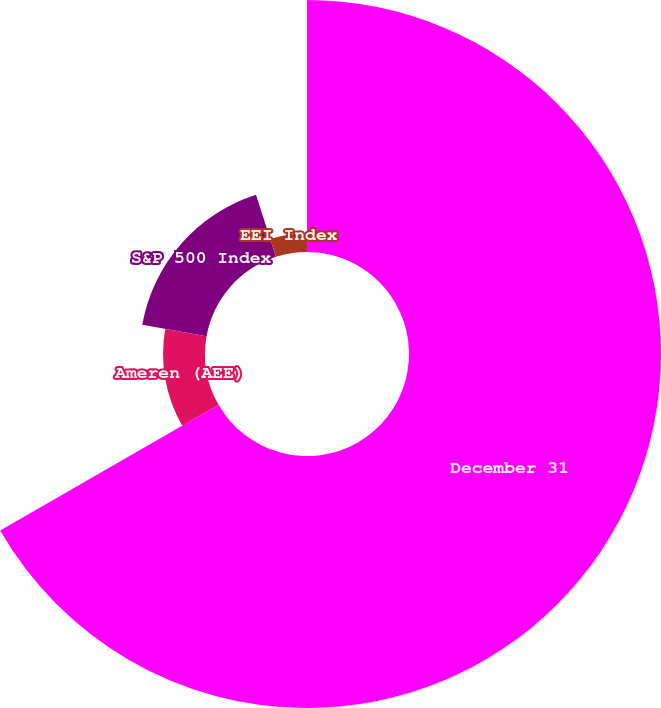<chart> <loc_0><loc_0><loc_500><loc_500><pie_chart><fcel>December 31<fcel>Ameren (AEE)<fcel>S&P 500 Index<fcel>EEI Index<nl><fcel>66.69%<fcel>11.1%<fcel>17.28%<fcel>4.93%<nl></chart> 